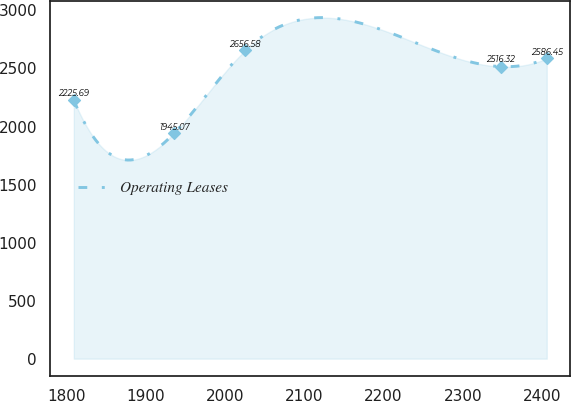Convert chart. <chart><loc_0><loc_0><loc_500><loc_500><line_chart><ecel><fcel>Operating Leases<nl><fcel>1809.61<fcel>2225.69<nl><fcel>1936.49<fcel>1945.07<nl><fcel>2025.78<fcel>2656.58<nl><fcel>2347.35<fcel>2516.32<nl><fcel>2405.62<fcel>2586.45<nl></chart> 